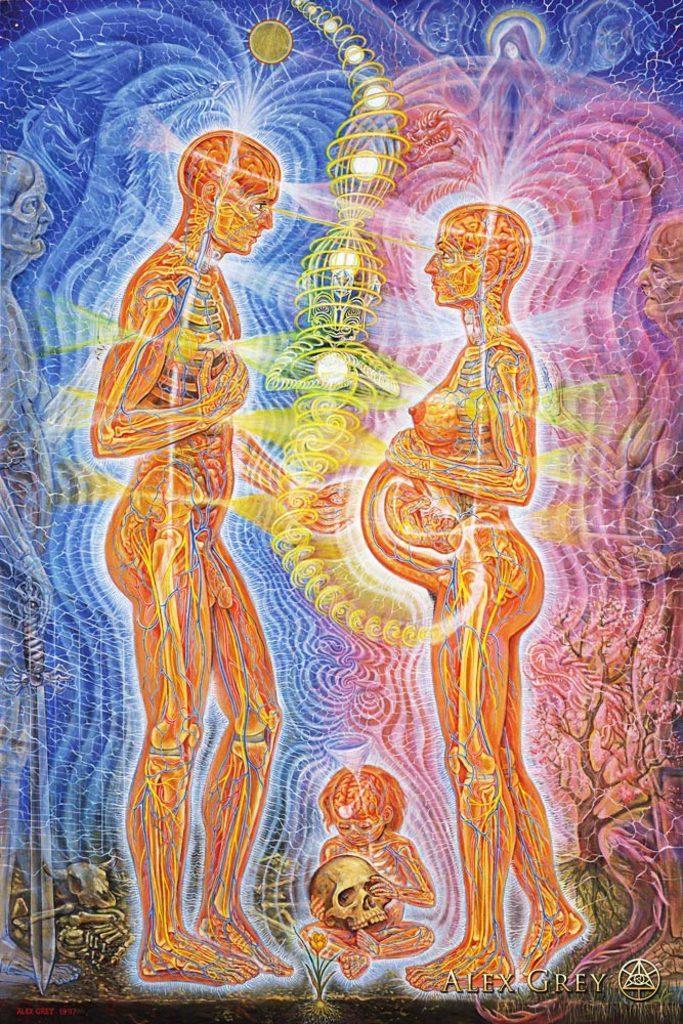In one or two sentences, can you explain what this image depicts? This is a graphical image of a man and a woman. 